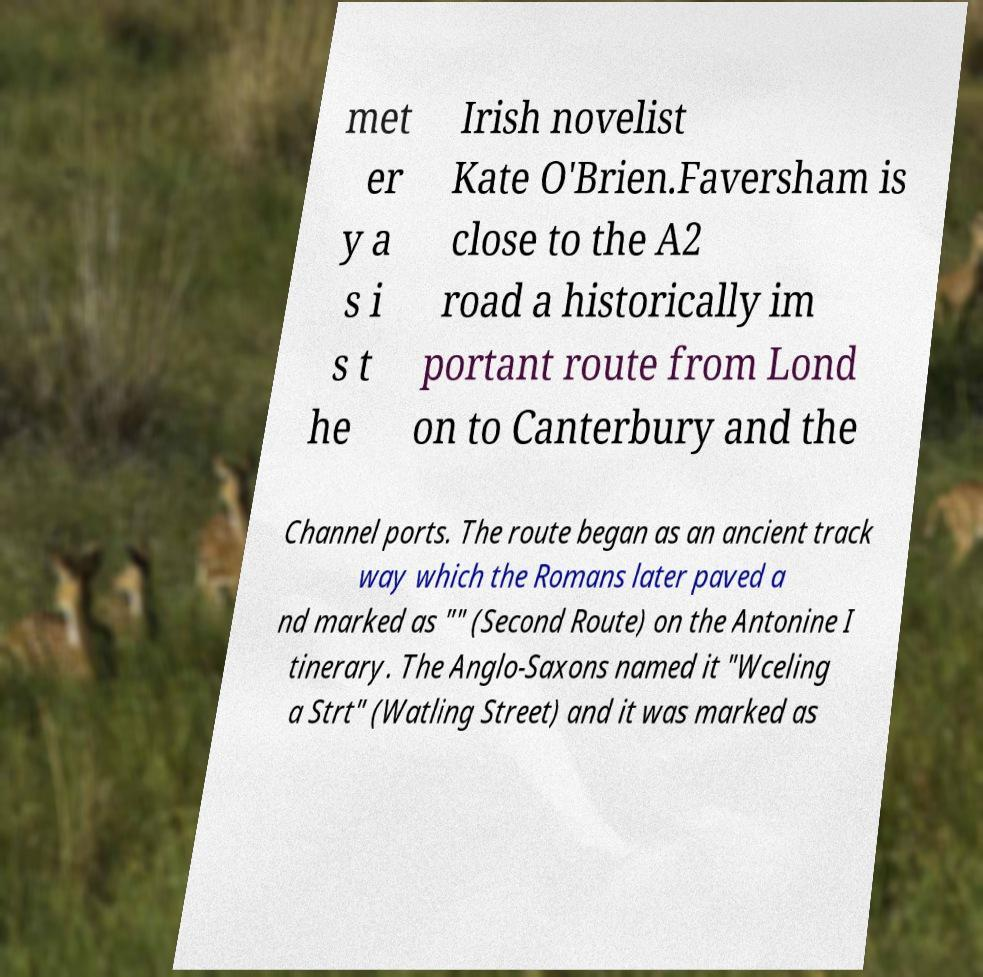For documentation purposes, I need the text within this image transcribed. Could you provide that? met er y a s i s t he Irish novelist Kate O'Brien.Faversham is close to the A2 road a historically im portant route from Lond on to Canterbury and the Channel ports. The route began as an ancient track way which the Romans later paved a nd marked as "" (Second Route) on the Antonine I tinerary. The Anglo-Saxons named it "Wceling a Strt" (Watling Street) and it was marked as 